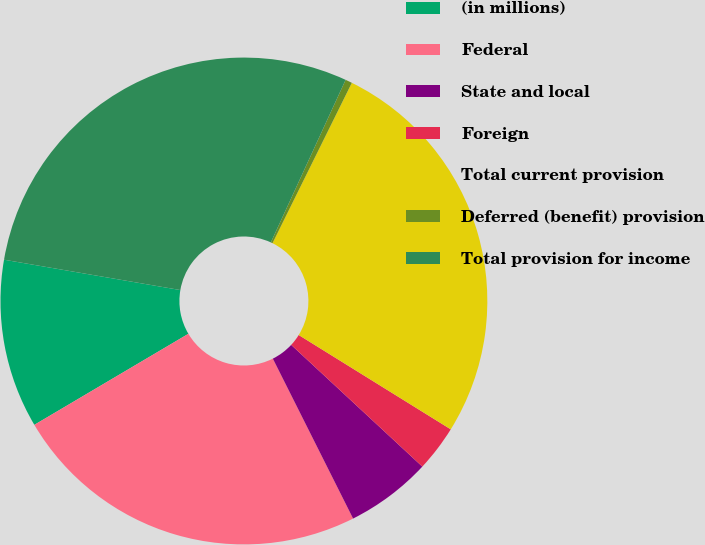<chart> <loc_0><loc_0><loc_500><loc_500><pie_chart><fcel>(in millions)<fcel>Federal<fcel>State and local<fcel>Foreign<fcel>Total current provision<fcel>Deferred (benefit) provision<fcel>Total provision for income<nl><fcel>11.21%<fcel>23.91%<fcel>5.69%<fcel>3.07%<fcel>26.53%<fcel>0.45%<fcel>29.15%<nl></chart> 